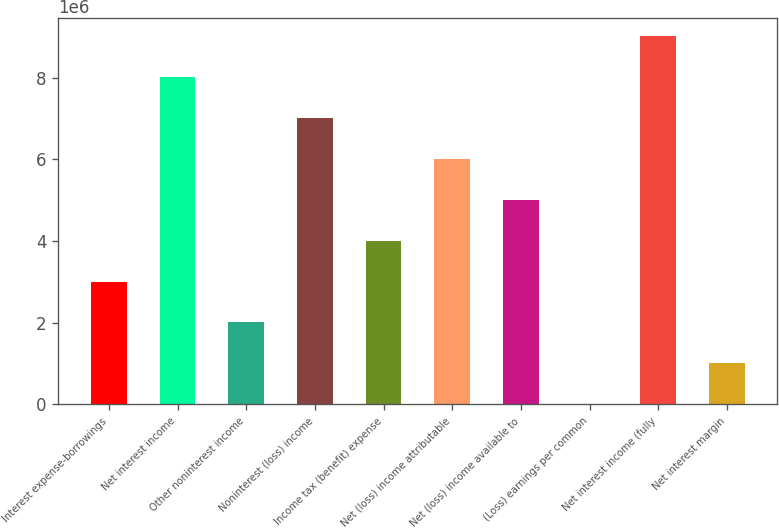<chart> <loc_0><loc_0><loc_500><loc_500><bar_chart><fcel>Interest expense-borrowings<fcel>Net interest income<fcel>Other noninterest income<fcel>Noninterest (loss) income<fcel>Income tax (benefit) expense<fcel>Net (loss) income attributable<fcel>Net (loss) income available to<fcel>(Loss) earnings per common<fcel>Net interest income (fully<fcel>Net interest margin<nl><fcel>3.00627e+06<fcel>8.01671e+06<fcel>2.00418e+06<fcel>7.01463e+06<fcel>4.00836e+06<fcel>6.01254e+06<fcel>5.01045e+06<fcel>2.29<fcel>9.0188e+06<fcel>1.00209e+06<nl></chart> 